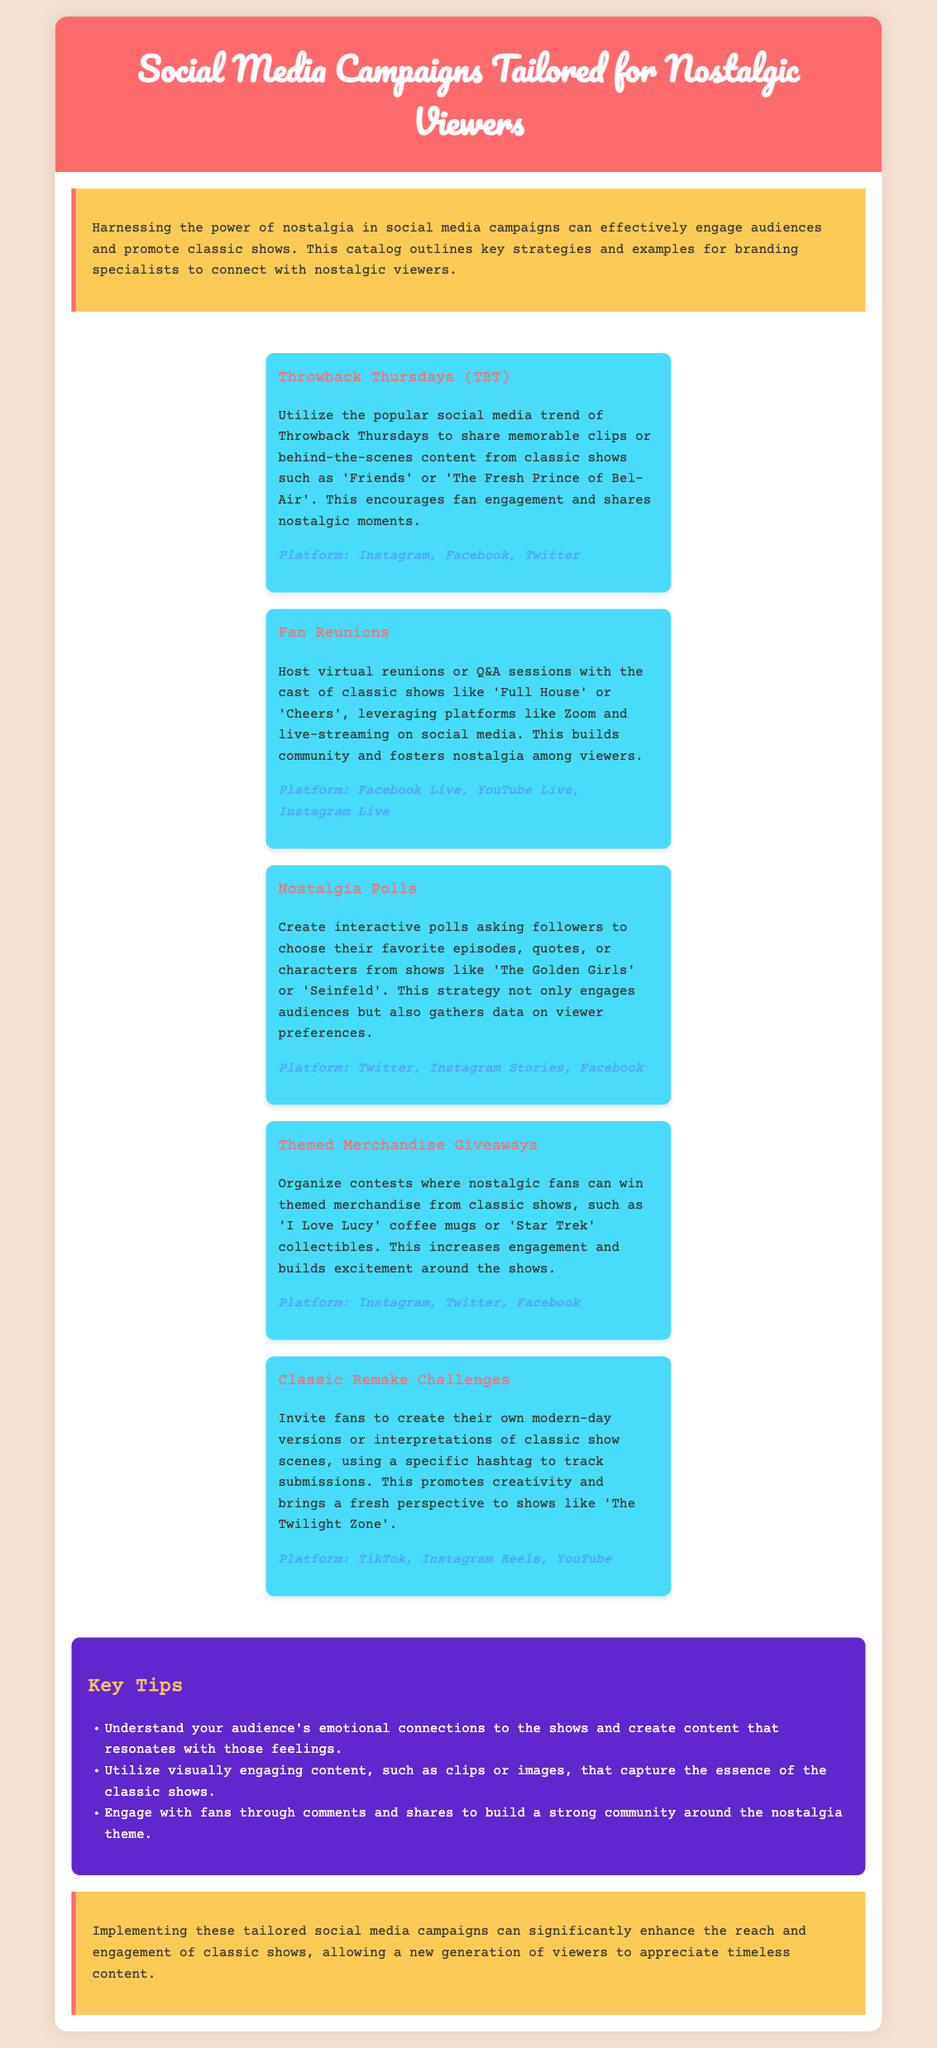What is the main purpose of the catalog? The catalog outlines key strategies and examples for branding specialists to connect with nostalgic viewers.
Answer: To connect with nostalgic viewers What social media platform is suggested for Throwback Thursdays? The document lists Instagram, Facebook, and Twitter as platforms for this campaign.
Answer: Instagram, Facebook, Twitter How many key tips are provided in the document? There are three key tips mentioned in the key tips section.
Answer: Three What kind of giveaways are mentioned in the themed merchandise campaign? The campaign mentions contests for themed merchandise from classic shows.
Answer: Themed merchandise Which campaign encourages fan-created modern-day versions of classic scenes? The document describes the Classic Remake Challenges as the campaign for this purpose.
Answer: Classic Remake Challenges What emotional aspect should be understood according to the key tips? The tips suggest understanding the audience's emotional connections to the shows.
Answer: Emotional connections 